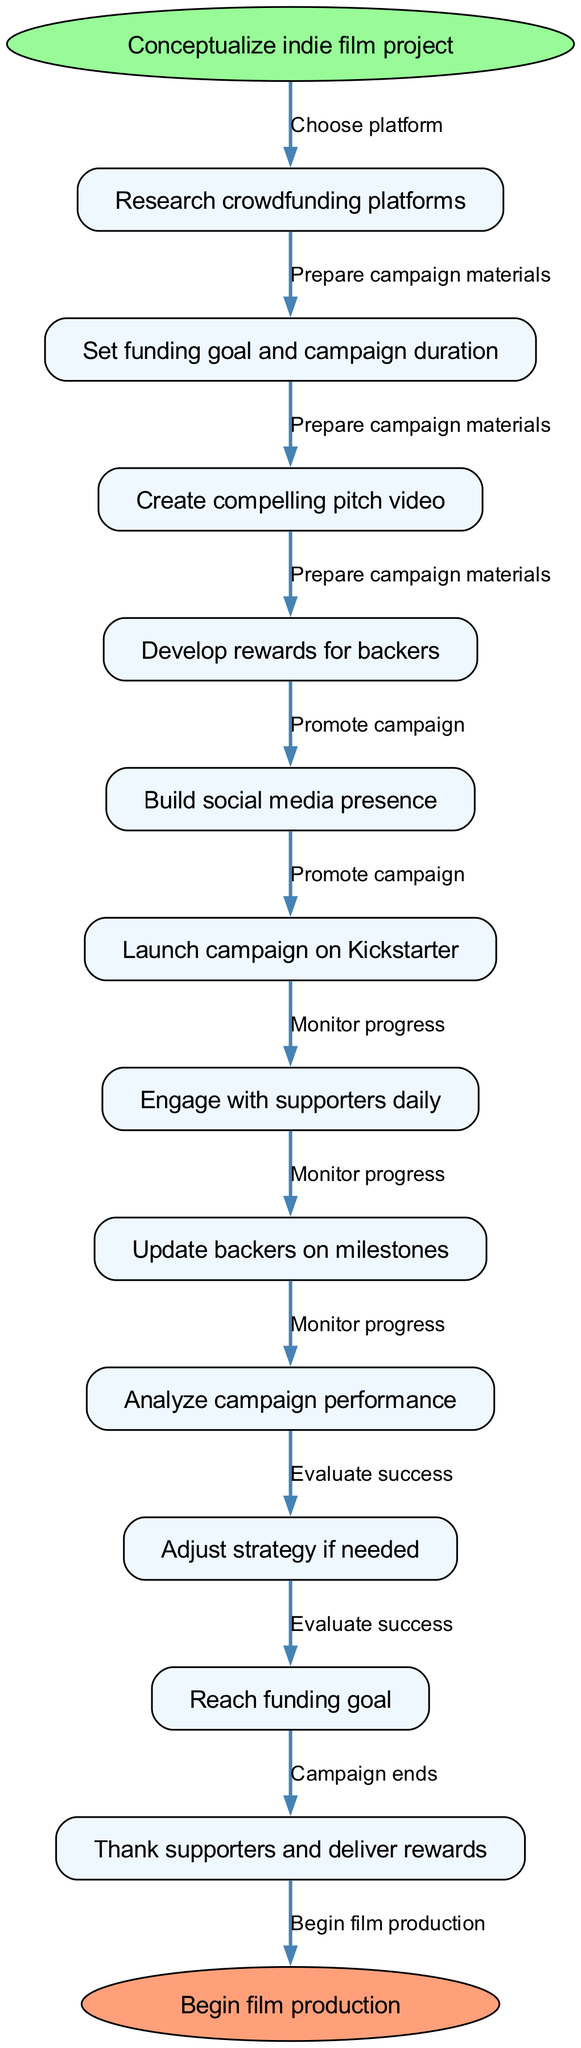What is the starting point of the diagram? The starting point, which is represented by the oval shape at the top of the flowchart, is the "Conceptualize indie film project" node.
Answer: Conceptualize indie film project How many nodes are there in total? There are 12 nodes in total, including the start and end nodes, as the data specifies one start node, multiple process nodes, and one end node.
Answer: 12 What is the last step before beginning film production? The last step before the end node is "Thank supporters and deliver rewards," which is indicated as the action that occurs just before transitioning to the "Begin film production" end node.
Answer: Thank supporters and deliver rewards What node comes after creating a compelling pitch video? After "Create compelling pitch video," the next node in the flowchart is "Develop rewards for backers," which is connected directly by an edge.
Answer: Develop rewards for backers What type of platform is indicated at the beginning of the flowchart? The type of platform mentioned at the beginning of the flowchart is "crowdfunding platform," which can be deduced from the first step where "Research crowdfunding platforms" is highlighted.
Answer: Crowdfunding platform How many edges are used in total? The flowchart includes 6 edges that connect the various nodes, representing the actions that lead from one step to another within the crowdfunding campaign management process.
Answer: 6 What is the edge indicating the action taken to start promoting the campaign? The edge indicating the action taken to start promoting the campaign is labeled "Promote campaign," which connects the nodes related to developing a social media presence and launching the campaign.
Answer: Promote campaign Which node is directly linked after setting the funding goal? The node that follows after "Set funding goal and campaign duration" is "Create compelling pitch video," showing the progression in the crowdfunding campaign management process.
Answer: Create compelling pitch video What is the purpose of engaging with supporters daily? The purpose of engaging with supporters daily is to maintain interaction and potentially increase backing and support for the campaign throughout its duration.
Answer: Increase backing and support 